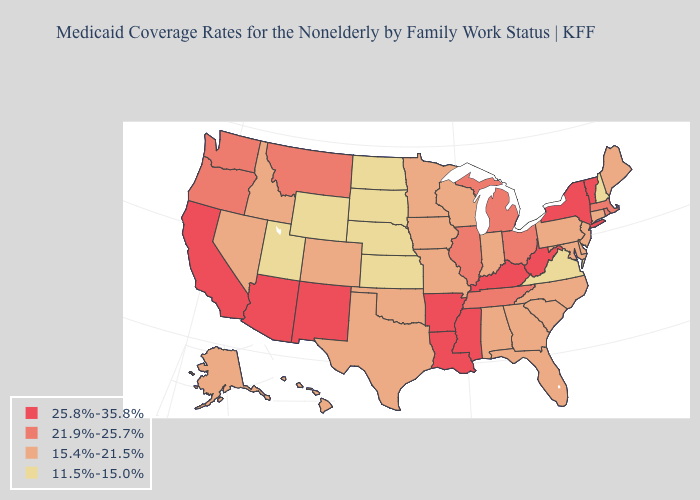Does South Dakota have the lowest value in the USA?
Write a very short answer. Yes. What is the value of Nevada?
Concise answer only. 15.4%-21.5%. What is the lowest value in the West?
Give a very brief answer. 11.5%-15.0%. Does Arizona have a higher value than Colorado?
Write a very short answer. Yes. Which states have the lowest value in the USA?
Be succinct. Kansas, Nebraska, New Hampshire, North Dakota, South Dakota, Utah, Virginia, Wyoming. What is the highest value in the USA?
Give a very brief answer. 25.8%-35.8%. Which states have the highest value in the USA?
Write a very short answer. Arizona, Arkansas, California, Kentucky, Louisiana, Mississippi, New Mexico, New York, Vermont, West Virginia. What is the value of Georgia?
Quick response, please. 15.4%-21.5%. What is the value of Massachusetts?
Concise answer only. 21.9%-25.7%. What is the highest value in the USA?
Give a very brief answer. 25.8%-35.8%. Among the states that border Ohio , does Michigan have the lowest value?
Be succinct. No. What is the value of Indiana?
Give a very brief answer. 15.4%-21.5%. Name the states that have a value in the range 11.5%-15.0%?
Write a very short answer. Kansas, Nebraska, New Hampshire, North Dakota, South Dakota, Utah, Virginia, Wyoming. What is the value of Connecticut?
Keep it brief. 15.4%-21.5%. 